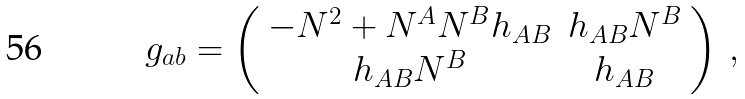<formula> <loc_0><loc_0><loc_500><loc_500>g _ { a b } = \left ( \begin{array} { c c } - N ^ { 2 } + N ^ { A } N ^ { B } h _ { A B } & h _ { A B } N ^ { B } \\ h _ { A B } N ^ { B } & h _ { A B } \end{array} \right ) \, ,</formula> 